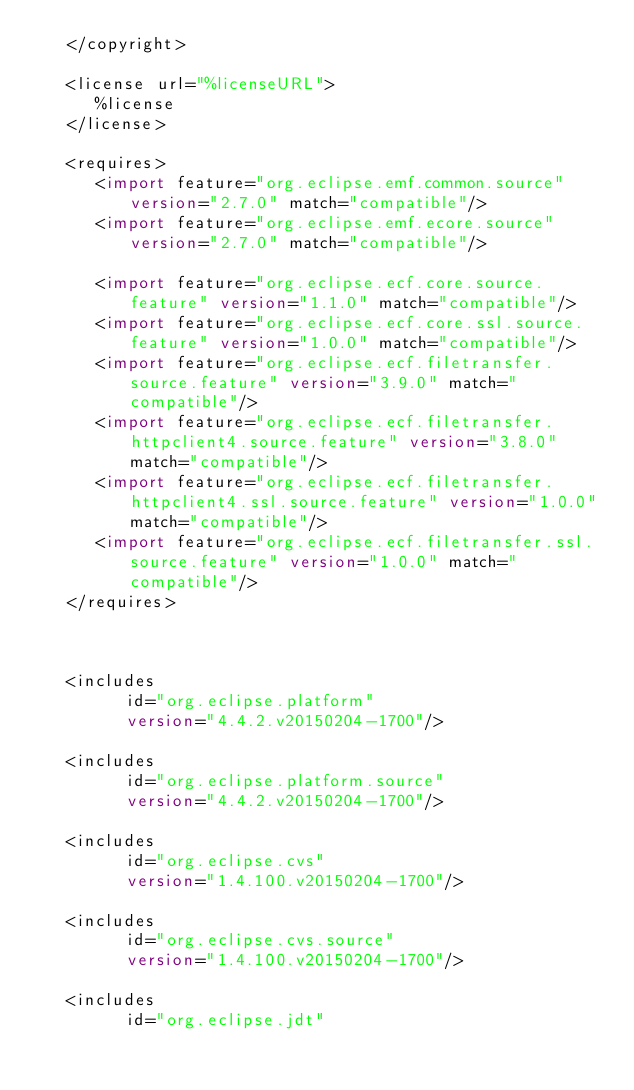Convert code to text. <code><loc_0><loc_0><loc_500><loc_500><_XML_>   </copyright>

   <license url="%licenseURL">
      %license
   </license>

   <requires>
      <import feature="org.eclipse.emf.common.source" version="2.7.0" match="compatible"/>
      <import feature="org.eclipse.emf.ecore.source" version="2.7.0" match="compatible"/>
   
      <import feature="org.eclipse.ecf.core.source.feature" version="1.1.0" match="compatible"/>
      <import feature="org.eclipse.ecf.core.ssl.source.feature" version="1.0.0" match="compatible"/>
      <import feature="org.eclipse.ecf.filetransfer.source.feature" version="3.9.0" match="compatible"/>
      <import feature="org.eclipse.ecf.filetransfer.httpclient4.source.feature" version="3.8.0" match="compatible"/>
      <import feature="org.eclipse.ecf.filetransfer.httpclient4.ssl.source.feature" version="1.0.0" match="compatible"/>
      <import feature="org.eclipse.ecf.filetransfer.ssl.source.feature" version="1.0.0" match="compatible"/>
   </requires>



   <includes
         id="org.eclipse.platform"
         version="4.4.2.v20150204-1700"/>

   <includes
         id="org.eclipse.platform.source"
         version="4.4.2.v20150204-1700"/>

   <includes
         id="org.eclipse.cvs"
         version="1.4.100.v20150204-1700"/>

   <includes
         id="org.eclipse.cvs.source"
         version="1.4.100.v20150204-1700"/>

   <includes
         id="org.eclipse.jdt"</code> 